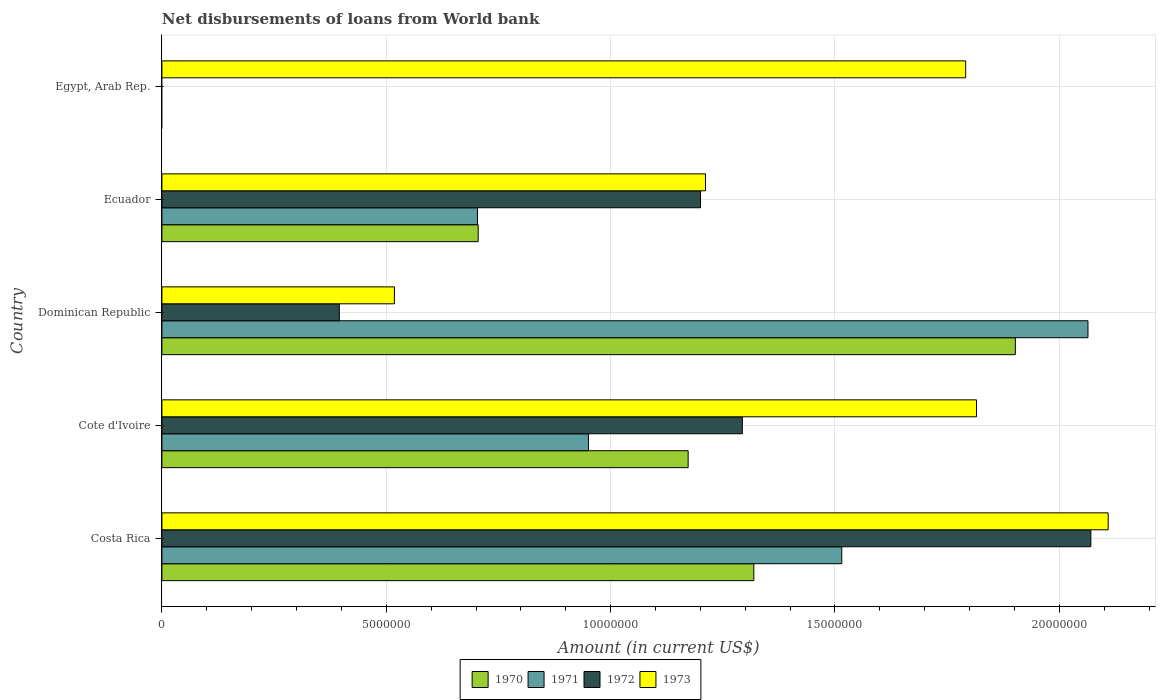Are the number of bars per tick equal to the number of legend labels?
Your answer should be compact. No. Are the number of bars on each tick of the Y-axis equal?
Give a very brief answer. No. How many bars are there on the 5th tick from the top?
Make the answer very short. 4. What is the label of the 2nd group of bars from the top?
Keep it short and to the point. Ecuador. In how many cases, is the number of bars for a given country not equal to the number of legend labels?
Provide a succinct answer. 1. What is the amount of loan disbursed from World Bank in 1971 in Ecuador?
Make the answer very short. 7.03e+06. Across all countries, what is the maximum amount of loan disbursed from World Bank in 1972?
Keep it short and to the point. 2.07e+07. Across all countries, what is the minimum amount of loan disbursed from World Bank in 1973?
Offer a terse response. 5.18e+06. In which country was the amount of loan disbursed from World Bank in 1972 maximum?
Give a very brief answer. Costa Rica. What is the total amount of loan disbursed from World Bank in 1970 in the graph?
Your answer should be very brief. 5.10e+07. What is the difference between the amount of loan disbursed from World Bank in 1970 in Costa Rica and that in Dominican Republic?
Your response must be concise. -5.83e+06. What is the difference between the amount of loan disbursed from World Bank in 1973 in Egypt, Arab Rep. and the amount of loan disbursed from World Bank in 1970 in Cote d'Ivoire?
Ensure brevity in your answer.  6.18e+06. What is the average amount of loan disbursed from World Bank in 1973 per country?
Provide a succinct answer. 1.49e+07. What is the difference between the amount of loan disbursed from World Bank in 1971 and amount of loan disbursed from World Bank in 1972 in Dominican Republic?
Offer a terse response. 1.67e+07. What is the ratio of the amount of loan disbursed from World Bank in 1973 in Cote d'Ivoire to that in Ecuador?
Give a very brief answer. 1.5. Is the amount of loan disbursed from World Bank in 1970 in Dominican Republic less than that in Ecuador?
Your answer should be compact. No. Is the difference between the amount of loan disbursed from World Bank in 1971 in Costa Rica and Dominican Republic greater than the difference between the amount of loan disbursed from World Bank in 1972 in Costa Rica and Dominican Republic?
Ensure brevity in your answer.  No. What is the difference between the highest and the second highest amount of loan disbursed from World Bank in 1972?
Give a very brief answer. 7.77e+06. What is the difference between the highest and the lowest amount of loan disbursed from World Bank in 1972?
Keep it short and to the point. 2.07e+07. In how many countries, is the amount of loan disbursed from World Bank in 1971 greater than the average amount of loan disbursed from World Bank in 1971 taken over all countries?
Keep it short and to the point. 2. Is the sum of the amount of loan disbursed from World Bank in 1971 in Dominican Republic and Ecuador greater than the maximum amount of loan disbursed from World Bank in 1973 across all countries?
Make the answer very short. Yes. How many bars are there?
Make the answer very short. 17. How many countries are there in the graph?
Give a very brief answer. 5. Does the graph contain grids?
Provide a short and direct response. Yes. Where does the legend appear in the graph?
Offer a terse response. Bottom center. How are the legend labels stacked?
Provide a short and direct response. Horizontal. What is the title of the graph?
Ensure brevity in your answer.  Net disbursements of loans from World bank. What is the label or title of the Y-axis?
Your answer should be compact. Country. What is the Amount (in current US$) in 1970 in Costa Rica?
Make the answer very short. 1.32e+07. What is the Amount (in current US$) of 1971 in Costa Rica?
Give a very brief answer. 1.52e+07. What is the Amount (in current US$) in 1972 in Costa Rica?
Make the answer very short. 2.07e+07. What is the Amount (in current US$) of 1973 in Costa Rica?
Your answer should be very brief. 2.11e+07. What is the Amount (in current US$) of 1970 in Cote d'Ivoire?
Provide a short and direct response. 1.17e+07. What is the Amount (in current US$) of 1971 in Cote d'Ivoire?
Keep it short and to the point. 9.51e+06. What is the Amount (in current US$) in 1972 in Cote d'Ivoire?
Provide a succinct answer. 1.29e+07. What is the Amount (in current US$) in 1973 in Cote d'Ivoire?
Give a very brief answer. 1.82e+07. What is the Amount (in current US$) in 1970 in Dominican Republic?
Make the answer very short. 1.90e+07. What is the Amount (in current US$) in 1971 in Dominican Republic?
Offer a terse response. 2.06e+07. What is the Amount (in current US$) in 1972 in Dominican Republic?
Make the answer very short. 3.95e+06. What is the Amount (in current US$) of 1973 in Dominican Republic?
Your answer should be compact. 5.18e+06. What is the Amount (in current US$) of 1970 in Ecuador?
Your response must be concise. 7.05e+06. What is the Amount (in current US$) of 1971 in Ecuador?
Provide a succinct answer. 7.03e+06. What is the Amount (in current US$) in 1972 in Ecuador?
Provide a short and direct response. 1.20e+07. What is the Amount (in current US$) in 1973 in Ecuador?
Ensure brevity in your answer.  1.21e+07. What is the Amount (in current US$) of 1971 in Egypt, Arab Rep.?
Ensure brevity in your answer.  0. What is the Amount (in current US$) in 1972 in Egypt, Arab Rep.?
Ensure brevity in your answer.  0. What is the Amount (in current US$) in 1973 in Egypt, Arab Rep.?
Give a very brief answer. 1.79e+07. Across all countries, what is the maximum Amount (in current US$) of 1970?
Offer a very short reply. 1.90e+07. Across all countries, what is the maximum Amount (in current US$) in 1971?
Offer a very short reply. 2.06e+07. Across all countries, what is the maximum Amount (in current US$) in 1972?
Offer a terse response. 2.07e+07. Across all countries, what is the maximum Amount (in current US$) of 1973?
Provide a succinct answer. 2.11e+07. Across all countries, what is the minimum Amount (in current US$) of 1970?
Provide a succinct answer. 0. Across all countries, what is the minimum Amount (in current US$) of 1972?
Offer a very short reply. 0. Across all countries, what is the minimum Amount (in current US$) in 1973?
Your answer should be compact. 5.18e+06. What is the total Amount (in current US$) of 1970 in the graph?
Ensure brevity in your answer.  5.10e+07. What is the total Amount (in current US$) of 1971 in the graph?
Offer a terse response. 5.23e+07. What is the total Amount (in current US$) in 1972 in the graph?
Make the answer very short. 4.96e+07. What is the total Amount (in current US$) in 1973 in the graph?
Keep it short and to the point. 7.45e+07. What is the difference between the Amount (in current US$) in 1970 in Costa Rica and that in Cote d'Ivoire?
Your answer should be compact. 1.46e+06. What is the difference between the Amount (in current US$) in 1971 in Costa Rica and that in Cote d'Ivoire?
Provide a succinct answer. 5.65e+06. What is the difference between the Amount (in current US$) of 1972 in Costa Rica and that in Cote d'Ivoire?
Ensure brevity in your answer.  7.77e+06. What is the difference between the Amount (in current US$) of 1973 in Costa Rica and that in Cote d'Ivoire?
Offer a very short reply. 2.93e+06. What is the difference between the Amount (in current US$) in 1970 in Costa Rica and that in Dominican Republic?
Ensure brevity in your answer.  -5.83e+06. What is the difference between the Amount (in current US$) in 1971 in Costa Rica and that in Dominican Republic?
Offer a very short reply. -5.49e+06. What is the difference between the Amount (in current US$) of 1972 in Costa Rica and that in Dominican Republic?
Keep it short and to the point. 1.67e+07. What is the difference between the Amount (in current US$) of 1973 in Costa Rica and that in Dominican Republic?
Provide a short and direct response. 1.59e+07. What is the difference between the Amount (in current US$) of 1970 in Costa Rica and that in Ecuador?
Give a very brief answer. 6.14e+06. What is the difference between the Amount (in current US$) of 1971 in Costa Rica and that in Ecuador?
Your answer should be compact. 8.12e+06. What is the difference between the Amount (in current US$) in 1972 in Costa Rica and that in Ecuador?
Make the answer very short. 8.70e+06. What is the difference between the Amount (in current US$) in 1973 in Costa Rica and that in Ecuador?
Make the answer very short. 8.97e+06. What is the difference between the Amount (in current US$) of 1973 in Costa Rica and that in Egypt, Arab Rep.?
Make the answer very short. 3.18e+06. What is the difference between the Amount (in current US$) of 1970 in Cote d'Ivoire and that in Dominican Republic?
Your answer should be compact. -7.29e+06. What is the difference between the Amount (in current US$) in 1971 in Cote d'Ivoire and that in Dominican Republic?
Your response must be concise. -1.11e+07. What is the difference between the Amount (in current US$) in 1972 in Cote d'Ivoire and that in Dominican Republic?
Make the answer very short. 8.98e+06. What is the difference between the Amount (in current US$) in 1973 in Cote d'Ivoire and that in Dominican Republic?
Your answer should be very brief. 1.30e+07. What is the difference between the Amount (in current US$) of 1970 in Cote d'Ivoire and that in Ecuador?
Give a very brief answer. 4.68e+06. What is the difference between the Amount (in current US$) of 1971 in Cote d'Ivoire and that in Ecuador?
Offer a terse response. 2.47e+06. What is the difference between the Amount (in current US$) of 1972 in Cote d'Ivoire and that in Ecuador?
Ensure brevity in your answer.  9.32e+05. What is the difference between the Amount (in current US$) of 1973 in Cote d'Ivoire and that in Ecuador?
Your response must be concise. 6.04e+06. What is the difference between the Amount (in current US$) of 1973 in Cote d'Ivoire and that in Egypt, Arab Rep.?
Ensure brevity in your answer.  2.42e+05. What is the difference between the Amount (in current US$) of 1970 in Dominican Republic and that in Ecuador?
Your response must be concise. 1.20e+07. What is the difference between the Amount (in current US$) of 1971 in Dominican Republic and that in Ecuador?
Make the answer very short. 1.36e+07. What is the difference between the Amount (in current US$) of 1972 in Dominican Republic and that in Ecuador?
Keep it short and to the point. -8.05e+06. What is the difference between the Amount (in current US$) in 1973 in Dominican Republic and that in Ecuador?
Offer a very short reply. -6.93e+06. What is the difference between the Amount (in current US$) of 1973 in Dominican Republic and that in Egypt, Arab Rep.?
Give a very brief answer. -1.27e+07. What is the difference between the Amount (in current US$) in 1973 in Ecuador and that in Egypt, Arab Rep.?
Your response must be concise. -5.80e+06. What is the difference between the Amount (in current US$) in 1970 in Costa Rica and the Amount (in current US$) in 1971 in Cote d'Ivoire?
Your response must be concise. 3.69e+06. What is the difference between the Amount (in current US$) of 1970 in Costa Rica and the Amount (in current US$) of 1972 in Cote d'Ivoire?
Offer a very short reply. 2.56e+05. What is the difference between the Amount (in current US$) of 1970 in Costa Rica and the Amount (in current US$) of 1973 in Cote d'Ivoire?
Ensure brevity in your answer.  -4.96e+06. What is the difference between the Amount (in current US$) of 1971 in Costa Rica and the Amount (in current US$) of 1972 in Cote d'Ivoire?
Keep it short and to the point. 2.22e+06. What is the difference between the Amount (in current US$) in 1971 in Costa Rica and the Amount (in current US$) in 1973 in Cote d'Ivoire?
Provide a succinct answer. -3.00e+06. What is the difference between the Amount (in current US$) in 1972 in Costa Rica and the Amount (in current US$) in 1973 in Cote d'Ivoire?
Give a very brief answer. 2.55e+06. What is the difference between the Amount (in current US$) of 1970 in Costa Rica and the Amount (in current US$) of 1971 in Dominican Republic?
Offer a terse response. -7.45e+06. What is the difference between the Amount (in current US$) of 1970 in Costa Rica and the Amount (in current US$) of 1972 in Dominican Republic?
Your answer should be very brief. 9.24e+06. What is the difference between the Amount (in current US$) in 1970 in Costa Rica and the Amount (in current US$) in 1973 in Dominican Republic?
Your response must be concise. 8.01e+06. What is the difference between the Amount (in current US$) of 1971 in Costa Rica and the Amount (in current US$) of 1972 in Dominican Republic?
Ensure brevity in your answer.  1.12e+07. What is the difference between the Amount (in current US$) of 1971 in Costa Rica and the Amount (in current US$) of 1973 in Dominican Republic?
Ensure brevity in your answer.  9.97e+06. What is the difference between the Amount (in current US$) of 1972 in Costa Rica and the Amount (in current US$) of 1973 in Dominican Republic?
Make the answer very short. 1.55e+07. What is the difference between the Amount (in current US$) of 1970 in Costa Rica and the Amount (in current US$) of 1971 in Ecuador?
Your response must be concise. 6.16e+06. What is the difference between the Amount (in current US$) in 1970 in Costa Rica and the Amount (in current US$) in 1972 in Ecuador?
Offer a very short reply. 1.19e+06. What is the difference between the Amount (in current US$) of 1970 in Costa Rica and the Amount (in current US$) of 1973 in Ecuador?
Give a very brief answer. 1.08e+06. What is the difference between the Amount (in current US$) of 1971 in Costa Rica and the Amount (in current US$) of 1972 in Ecuador?
Your answer should be very brief. 3.15e+06. What is the difference between the Amount (in current US$) of 1971 in Costa Rica and the Amount (in current US$) of 1973 in Ecuador?
Give a very brief answer. 3.04e+06. What is the difference between the Amount (in current US$) of 1972 in Costa Rica and the Amount (in current US$) of 1973 in Ecuador?
Make the answer very short. 8.59e+06. What is the difference between the Amount (in current US$) in 1970 in Costa Rica and the Amount (in current US$) in 1973 in Egypt, Arab Rep.?
Your answer should be very brief. -4.72e+06. What is the difference between the Amount (in current US$) of 1971 in Costa Rica and the Amount (in current US$) of 1973 in Egypt, Arab Rep.?
Your response must be concise. -2.76e+06. What is the difference between the Amount (in current US$) in 1972 in Costa Rica and the Amount (in current US$) in 1973 in Egypt, Arab Rep.?
Make the answer very short. 2.79e+06. What is the difference between the Amount (in current US$) of 1970 in Cote d'Ivoire and the Amount (in current US$) of 1971 in Dominican Republic?
Make the answer very short. -8.91e+06. What is the difference between the Amount (in current US$) in 1970 in Cote d'Ivoire and the Amount (in current US$) in 1972 in Dominican Republic?
Ensure brevity in your answer.  7.77e+06. What is the difference between the Amount (in current US$) in 1970 in Cote d'Ivoire and the Amount (in current US$) in 1973 in Dominican Republic?
Make the answer very short. 6.55e+06. What is the difference between the Amount (in current US$) in 1971 in Cote d'Ivoire and the Amount (in current US$) in 1972 in Dominican Republic?
Ensure brevity in your answer.  5.55e+06. What is the difference between the Amount (in current US$) of 1971 in Cote d'Ivoire and the Amount (in current US$) of 1973 in Dominican Republic?
Offer a terse response. 4.32e+06. What is the difference between the Amount (in current US$) of 1972 in Cote d'Ivoire and the Amount (in current US$) of 1973 in Dominican Republic?
Keep it short and to the point. 7.75e+06. What is the difference between the Amount (in current US$) in 1970 in Cote d'Ivoire and the Amount (in current US$) in 1971 in Ecuador?
Offer a terse response. 4.69e+06. What is the difference between the Amount (in current US$) in 1970 in Cote d'Ivoire and the Amount (in current US$) in 1972 in Ecuador?
Provide a short and direct response. -2.76e+05. What is the difference between the Amount (in current US$) of 1970 in Cote d'Ivoire and the Amount (in current US$) of 1973 in Ecuador?
Make the answer very short. -3.87e+05. What is the difference between the Amount (in current US$) of 1971 in Cote d'Ivoire and the Amount (in current US$) of 1972 in Ecuador?
Provide a succinct answer. -2.50e+06. What is the difference between the Amount (in current US$) in 1971 in Cote d'Ivoire and the Amount (in current US$) in 1973 in Ecuador?
Provide a short and direct response. -2.61e+06. What is the difference between the Amount (in current US$) of 1972 in Cote d'Ivoire and the Amount (in current US$) of 1973 in Ecuador?
Ensure brevity in your answer.  8.21e+05. What is the difference between the Amount (in current US$) in 1970 in Cote d'Ivoire and the Amount (in current US$) in 1973 in Egypt, Arab Rep.?
Ensure brevity in your answer.  -6.18e+06. What is the difference between the Amount (in current US$) of 1971 in Cote d'Ivoire and the Amount (in current US$) of 1973 in Egypt, Arab Rep.?
Give a very brief answer. -8.41e+06. What is the difference between the Amount (in current US$) of 1972 in Cote d'Ivoire and the Amount (in current US$) of 1973 in Egypt, Arab Rep.?
Ensure brevity in your answer.  -4.98e+06. What is the difference between the Amount (in current US$) in 1970 in Dominican Republic and the Amount (in current US$) in 1971 in Ecuador?
Your response must be concise. 1.20e+07. What is the difference between the Amount (in current US$) in 1970 in Dominican Republic and the Amount (in current US$) in 1972 in Ecuador?
Your answer should be very brief. 7.02e+06. What is the difference between the Amount (in current US$) of 1970 in Dominican Republic and the Amount (in current US$) of 1973 in Ecuador?
Your response must be concise. 6.90e+06. What is the difference between the Amount (in current US$) of 1971 in Dominican Republic and the Amount (in current US$) of 1972 in Ecuador?
Give a very brief answer. 8.64e+06. What is the difference between the Amount (in current US$) of 1971 in Dominican Republic and the Amount (in current US$) of 1973 in Ecuador?
Your answer should be very brief. 8.52e+06. What is the difference between the Amount (in current US$) of 1972 in Dominican Republic and the Amount (in current US$) of 1973 in Ecuador?
Offer a very short reply. -8.16e+06. What is the difference between the Amount (in current US$) in 1970 in Dominican Republic and the Amount (in current US$) in 1973 in Egypt, Arab Rep.?
Offer a very short reply. 1.11e+06. What is the difference between the Amount (in current US$) in 1971 in Dominican Republic and the Amount (in current US$) in 1973 in Egypt, Arab Rep.?
Ensure brevity in your answer.  2.73e+06. What is the difference between the Amount (in current US$) in 1972 in Dominican Republic and the Amount (in current US$) in 1973 in Egypt, Arab Rep.?
Your answer should be very brief. -1.40e+07. What is the difference between the Amount (in current US$) of 1970 in Ecuador and the Amount (in current US$) of 1973 in Egypt, Arab Rep.?
Give a very brief answer. -1.09e+07. What is the difference between the Amount (in current US$) of 1971 in Ecuador and the Amount (in current US$) of 1973 in Egypt, Arab Rep.?
Offer a very short reply. -1.09e+07. What is the difference between the Amount (in current US$) of 1972 in Ecuador and the Amount (in current US$) of 1973 in Egypt, Arab Rep.?
Your answer should be compact. -5.91e+06. What is the average Amount (in current US$) of 1970 per country?
Give a very brief answer. 1.02e+07. What is the average Amount (in current US$) of 1971 per country?
Provide a succinct answer. 1.05e+07. What is the average Amount (in current US$) in 1972 per country?
Keep it short and to the point. 9.92e+06. What is the average Amount (in current US$) of 1973 per country?
Offer a terse response. 1.49e+07. What is the difference between the Amount (in current US$) in 1970 and Amount (in current US$) in 1971 in Costa Rica?
Provide a succinct answer. -1.96e+06. What is the difference between the Amount (in current US$) in 1970 and Amount (in current US$) in 1972 in Costa Rica?
Your response must be concise. -7.51e+06. What is the difference between the Amount (in current US$) of 1970 and Amount (in current US$) of 1973 in Costa Rica?
Your response must be concise. -7.90e+06. What is the difference between the Amount (in current US$) in 1971 and Amount (in current US$) in 1972 in Costa Rica?
Offer a very short reply. -5.55e+06. What is the difference between the Amount (in current US$) of 1971 and Amount (in current US$) of 1973 in Costa Rica?
Keep it short and to the point. -5.94e+06. What is the difference between the Amount (in current US$) in 1972 and Amount (in current US$) in 1973 in Costa Rica?
Give a very brief answer. -3.86e+05. What is the difference between the Amount (in current US$) of 1970 and Amount (in current US$) of 1971 in Cote d'Ivoire?
Make the answer very short. 2.22e+06. What is the difference between the Amount (in current US$) in 1970 and Amount (in current US$) in 1972 in Cote d'Ivoire?
Make the answer very short. -1.21e+06. What is the difference between the Amount (in current US$) of 1970 and Amount (in current US$) of 1973 in Cote d'Ivoire?
Ensure brevity in your answer.  -6.43e+06. What is the difference between the Amount (in current US$) of 1971 and Amount (in current US$) of 1972 in Cote d'Ivoire?
Provide a succinct answer. -3.43e+06. What is the difference between the Amount (in current US$) of 1971 and Amount (in current US$) of 1973 in Cote d'Ivoire?
Offer a very short reply. -8.65e+06. What is the difference between the Amount (in current US$) of 1972 and Amount (in current US$) of 1973 in Cote d'Ivoire?
Offer a terse response. -5.22e+06. What is the difference between the Amount (in current US$) of 1970 and Amount (in current US$) of 1971 in Dominican Republic?
Provide a succinct answer. -1.62e+06. What is the difference between the Amount (in current US$) of 1970 and Amount (in current US$) of 1972 in Dominican Republic?
Give a very brief answer. 1.51e+07. What is the difference between the Amount (in current US$) in 1970 and Amount (in current US$) in 1973 in Dominican Republic?
Make the answer very short. 1.38e+07. What is the difference between the Amount (in current US$) of 1971 and Amount (in current US$) of 1972 in Dominican Republic?
Offer a very short reply. 1.67e+07. What is the difference between the Amount (in current US$) in 1971 and Amount (in current US$) in 1973 in Dominican Republic?
Provide a short and direct response. 1.55e+07. What is the difference between the Amount (in current US$) in 1972 and Amount (in current US$) in 1973 in Dominican Republic?
Keep it short and to the point. -1.23e+06. What is the difference between the Amount (in current US$) of 1970 and Amount (in current US$) of 1971 in Ecuador?
Offer a terse response. 1.50e+04. What is the difference between the Amount (in current US$) of 1970 and Amount (in current US$) of 1972 in Ecuador?
Ensure brevity in your answer.  -4.96e+06. What is the difference between the Amount (in current US$) of 1970 and Amount (in current US$) of 1973 in Ecuador?
Ensure brevity in your answer.  -5.07e+06. What is the difference between the Amount (in current US$) of 1971 and Amount (in current US$) of 1972 in Ecuador?
Make the answer very short. -4.97e+06. What is the difference between the Amount (in current US$) of 1971 and Amount (in current US$) of 1973 in Ecuador?
Ensure brevity in your answer.  -5.08e+06. What is the difference between the Amount (in current US$) in 1972 and Amount (in current US$) in 1973 in Ecuador?
Ensure brevity in your answer.  -1.11e+05. What is the ratio of the Amount (in current US$) in 1970 in Costa Rica to that in Cote d'Ivoire?
Offer a very short reply. 1.12. What is the ratio of the Amount (in current US$) in 1971 in Costa Rica to that in Cote d'Ivoire?
Provide a succinct answer. 1.59. What is the ratio of the Amount (in current US$) in 1972 in Costa Rica to that in Cote d'Ivoire?
Your answer should be compact. 1.6. What is the ratio of the Amount (in current US$) in 1973 in Costa Rica to that in Cote d'Ivoire?
Offer a very short reply. 1.16. What is the ratio of the Amount (in current US$) of 1970 in Costa Rica to that in Dominican Republic?
Make the answer very short. 0.69. What is the ratio of the Amount (in current US$) of 1971 in Costa Rica to that in Dominican Republic?
Offer a very short reply. 0.73. What is the ratio of the Amount (in current US$) of 1972 in Costa Rica to that in Dominican Republic?
Ensure brevity in your answer.  5.24. What is the ratio of the Amount (in current US$) in 1973 in Costa Rica to that in Dominican Republic?
Keep it short and to the point. 4.07. What is the ratio of the Amount (in current US$) in 1970 in Costa Rica to that in Ecuador?
Give a very brief answer. 1.87. What is the ratio of the Amount (in current US$) in 1971 in Costa Rica to that in Ecuador?
Provide a short and direct response. 2.15. What is the ratio of the Amount (in current US$) of 1972 in Costa Rica to that in Ecuador?
Your answer should be compact. 1.72. What is the ratio of the Amount (in current US$) in 1973 in Costa Rica to that in Ecuador?
Offer a very short reply. 1.74. What is the ratio of the Amount (in current US$) in 1973 in Costa Rica to that in Egypt, Arab Rep.?
Your response must be concise. 1.18. What is the ratio of the Amount (in current US$) in 1970 in Cote d'Ivoire to that in Dominican Republic?
Your answer should be compact. 0.62. What is the ratio of the Amount (in current US$) of 1971 in Cote d'Ivoire to that in Dominican Republic?
Make the answer very short. 0.46. What is the ratio of the Amount (in current US$) of 1972 in Cote d'Ivoire to that in Dominican Republic?
Your answer should be very brief. 3.27. What is the ratio of the Amount (in current US$) of 1973 in Cote d'Ivoire to that in Dominican Republic?
Provide a succinct answer. 3.5. What is the ratio of the Amount (in current US$) of 1970 in Cote d'Ivoire to that in Ecuador?
Ensure brevity in your answer.  1.66. What is the ratio of the Amount (in current US$) of 1971 in Cote d'Ivoire to that in Ecuador?
Your answer should be very brief. 1.35. What is the ratio of the Amount (in current US$) in 1972 in Cote d'Ivoire to that in Ecuador?
Make the answer very short. 1.08. What is the ratio of the Amount (in current US$) in 1973 in Cote d'Ivoire to that in Ecuador?
Give a very brief answer. 1.5. What is the ratio of the Amount (in current US$) in 1973 in Cote d'Ivoire to that in Egypt, Arab Rep.?
Ensure brevity in your answer.  1.01. What is the ratio of the Amount (in current US$) in 1970 in Dominican Republic to that in Ecuador?
Your response must be concise. 2.7. What is the ratio of the Amount (in current US$) of 1971 in Dominican Republic to that in Ecuador?
Your answer should be very brief. 2.93. What is the ratio of the Amount (in current US$) in 1972 in Dominican Republic to that in Ecuador?
Provide a succinct answer. 0.33. What is the ratio of the Amount (in current US$) of 1973 in Dominican Republic to that in Ecuador?
Keep it short and to the point. 0.43. What is the ratio of the Amount (in current US$) of 1973 in Dominican Republic to that in Egypt, Arab Rep.?
Make the answer very short. 0.29. What is the ratio of the Amount (in current US$) in 1973 in Ecuador to that in Egypt, Arab Rep.?
Offer a terse response. 0.68. What is the difference between the highest and the second highest Amount (in current US$) in 1970?
Offer a very short reply. 5.83e+06. What is the difference between the highest and the second highest Amount (in current US$) of 1971?
Provide a short and direct response. 5.49e+06. What is the difference between the highest and the second highest Amount (in current US$) in 1972?
Your answer should be very brief. 7.77e+06. What is the difference between the highest and the second highest Amount (in current US$) in 1973?
Offer a very short reply. 2.93e+06. What is the difference between the highest and the lowest Amount (in current US$) of 1970?
Make the answer very short. 1.90e+07. What is the difference between the highest and the lowest Amount (in current US$) of 1971?
Offer a very short reply. 2.06e+07. What is the difference between the highest and the lowest Amount (in current US$) in 1972?
Your answer should be very brief. 2.07e+07. What is the difference between the highest and the lowest Amount (in current US$) in 1973?
Provide a succinct answer. 1.59e+07. 